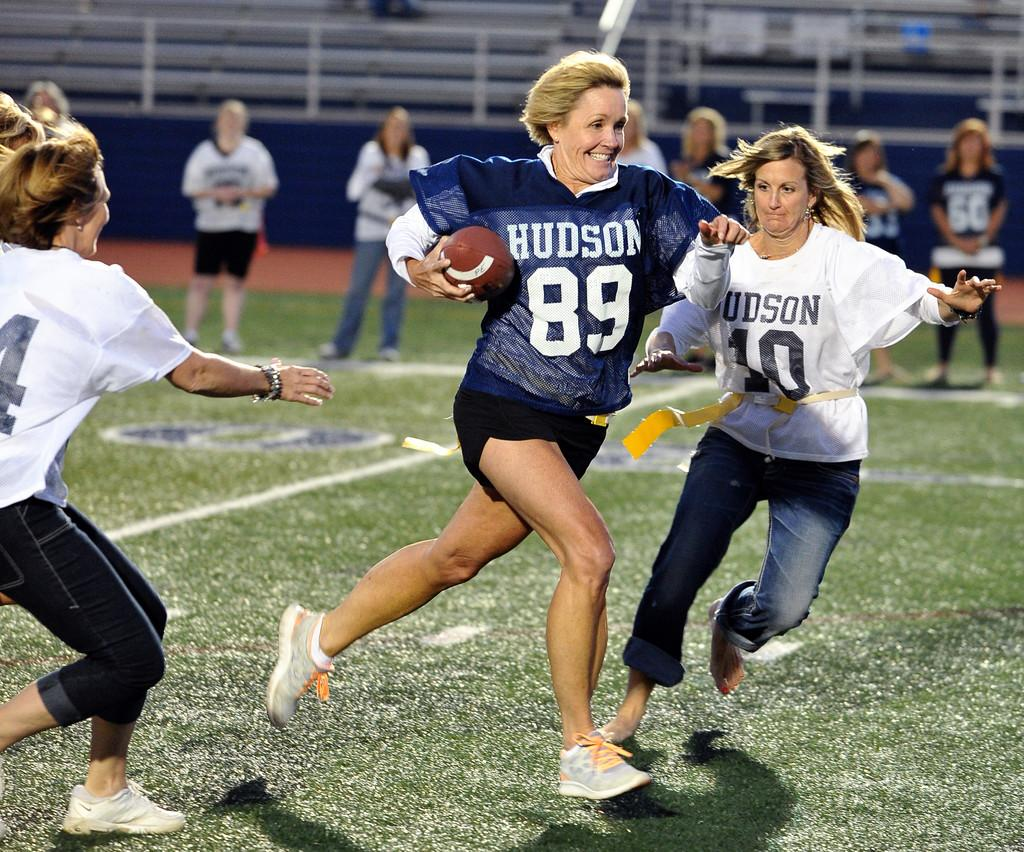What are the women in the image doing? There are three women running in the image. What is the woman in the middle holding? The woman in the middle is holding a rugby ball. What can be seen in the background of the image? There are people standing in the background, watching the women's game. What is the setting of the image? The setting appears to be a stadium. What type of plastic material is being used by the rabbits in the image? There are no rabbits present in the image, and therefore no plastic material can be observed. What decision is the woman in the middle making in the image? The image does not provide information about any decisions being made by the woman in the middle; she is simply holding a rugby ball while running. 